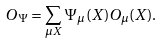Convert formula to latex. <formula><loc_0><loc_0><loc_500><loc_500>O _ { \Psi } = \sum _ { \mu X } \Psi _ { \mu } ( X ) O _ { \mu } ( X ) .</formula> 